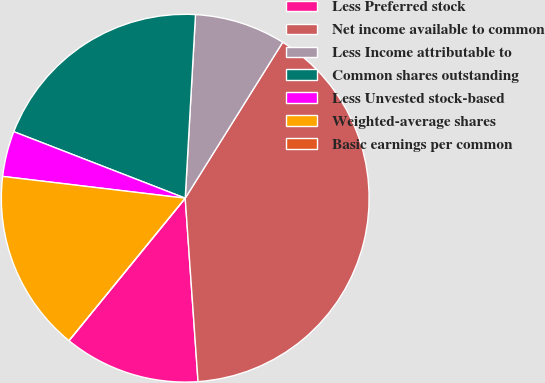<chart> <loc_0><loc_0><loc_500><loc_500><pie_chart><fcel>Less Preferred stock<fcel>Net income available to common<fcel>Less Income attributable to<fcel>Common shares outstanding<fcel>Less Unvested stock-based<fcel>Weighted-average shares<fcel>Basic earnings per common<nl><fcel>12.0%<fcel>40.0%<fcel>8.0%<fcel>20.0%<fcel>4.0%<fcel>16.0%<fcel>0.0%<nl></chart> 